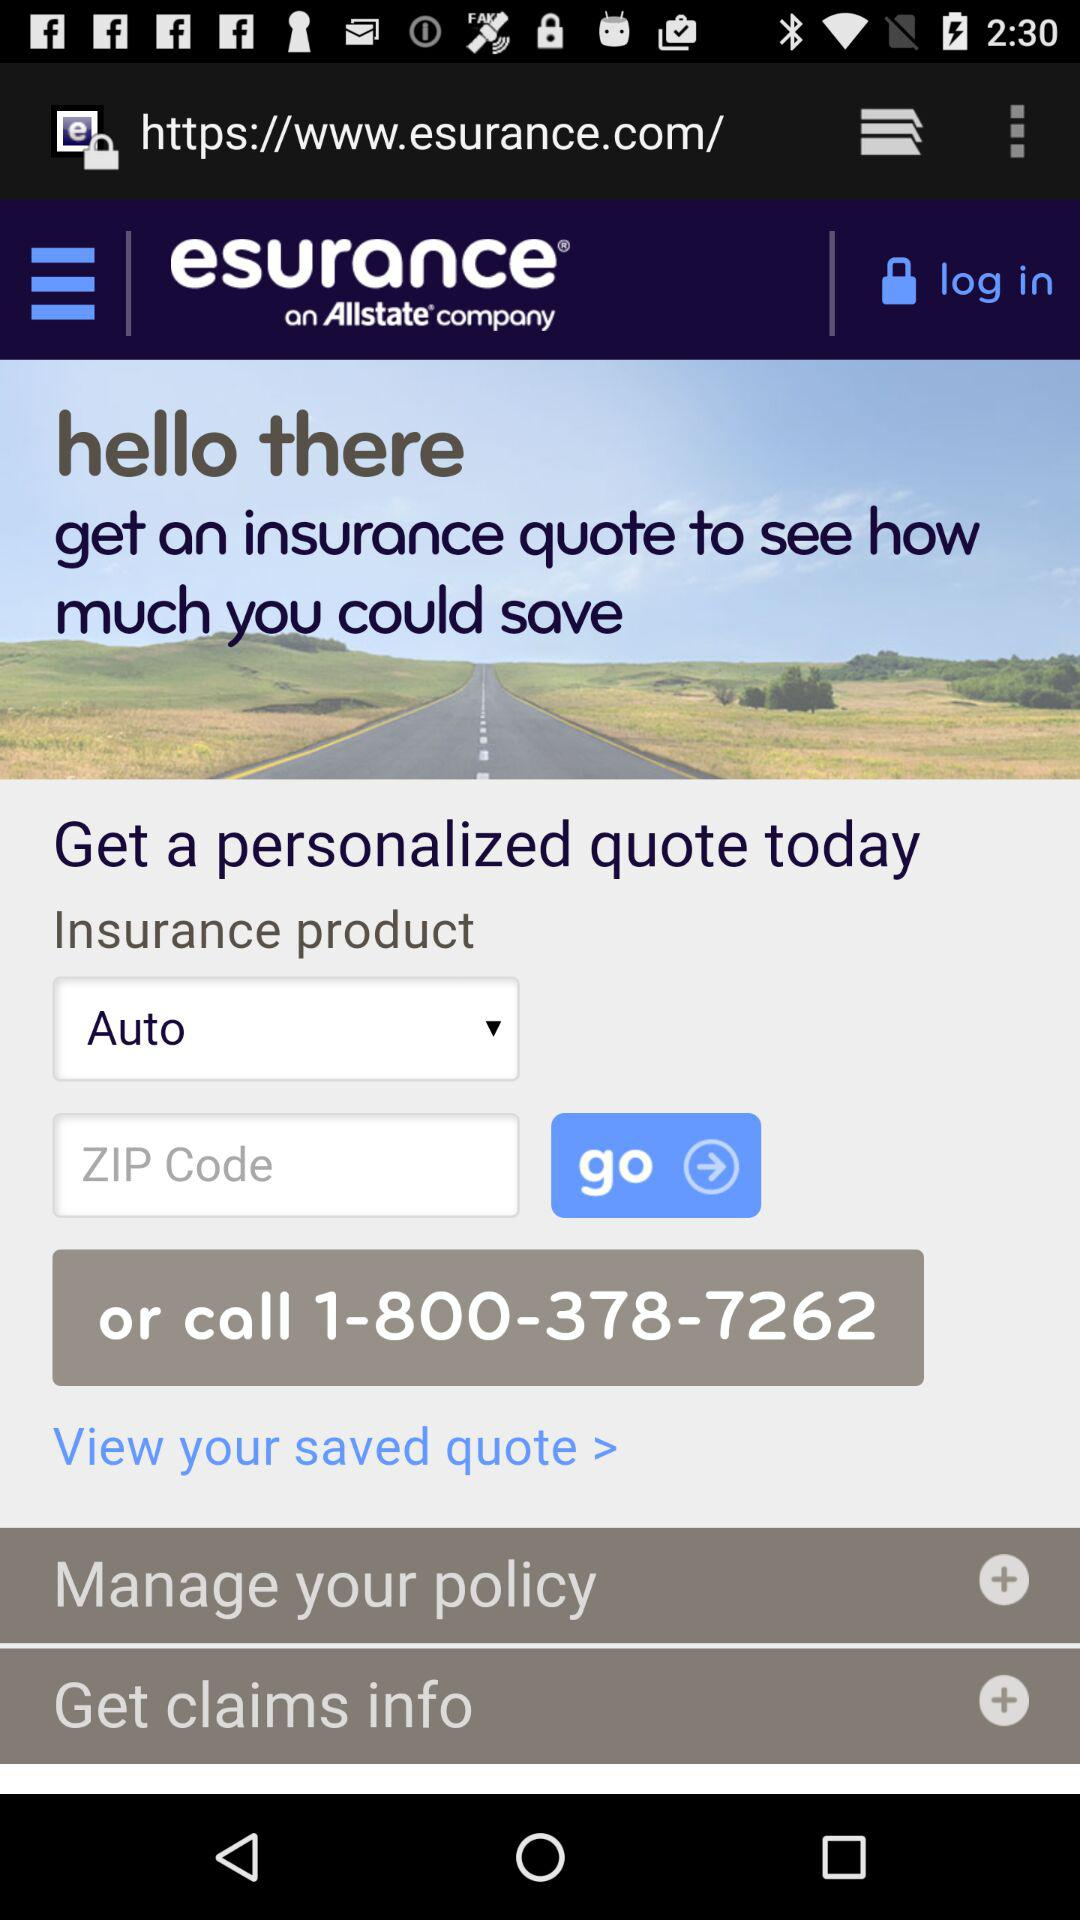What number should we call to get a personalized quote? You should call 1-800-378-7262 to get a personalized quote. 